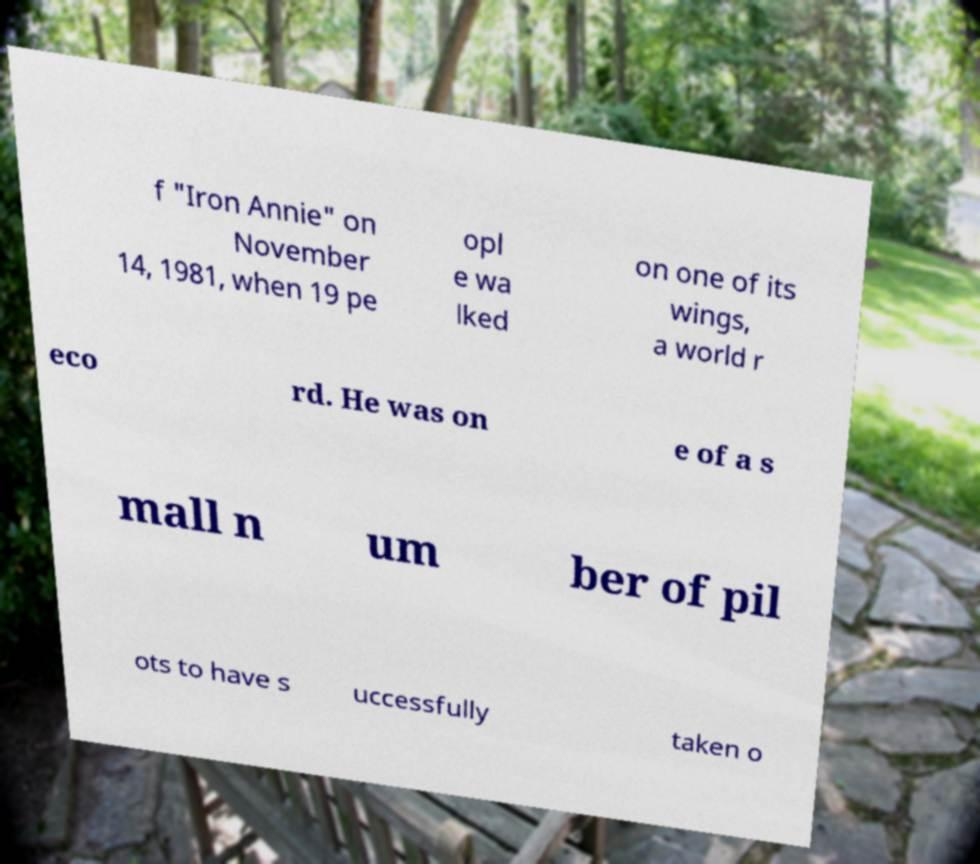Please read and relay the text visible in this image. What does it say? f "Iron Annie" on November 14, 1981, when 19 pe opl e wa lked on one of its wings, a world r eco rd. He was on e of a s mall n um ber of pil ots to have s uccessfully taken o 